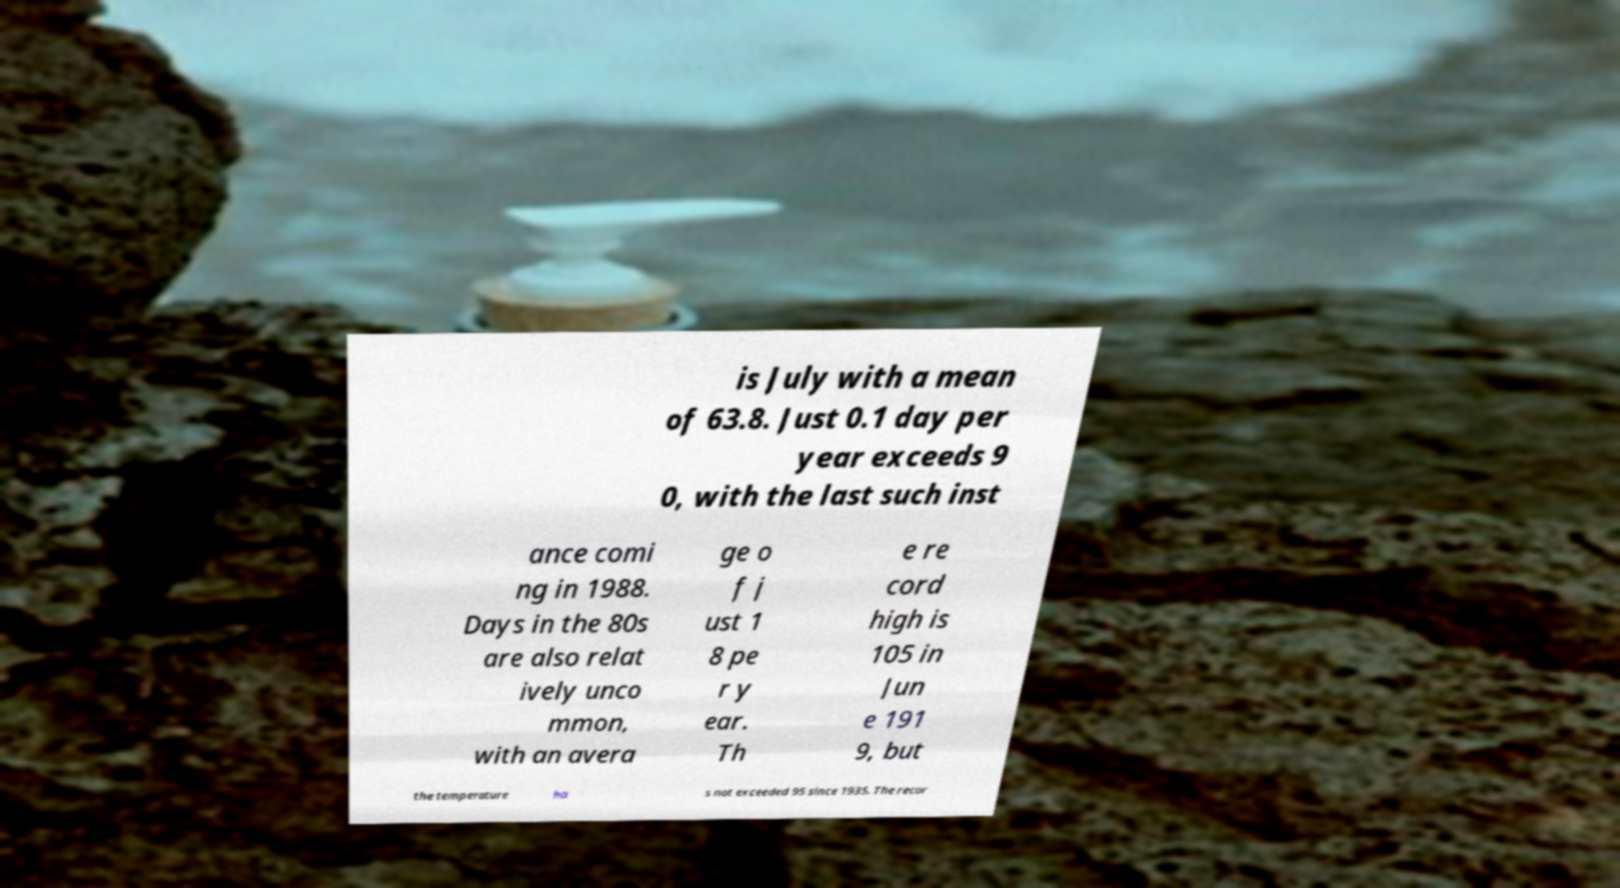What messages or text are displayed in this image? I need them in a readable, typed format. is July with a mean of 63.8. Just 0.1 day per year exceeds 9 0, with the last such inst ance comi ng in 1988. Days in the 80s are also relat ively unco mmon, with an avera ge o f j ust 1 8 pe r y ear. Th e re cord high is 105 in Jun e 191 9, but the temperature ha s not exceeded 95 since 1935. The recor 